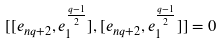<formula> <loc_0><loc_0><loc_500><loc_500>[ [ e _ { n q + 2 } , e _ { 1 } ^ { \frac { q - 1 } 2 } ] , [ e _ { n q + 2 } , e _ { 1 } ^ { \frac { q - 1 } 2 } ] ] = 0</formula> 